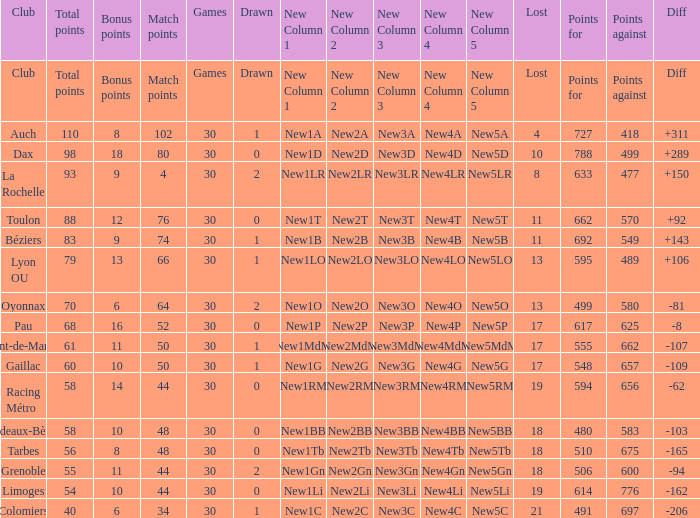What is the number of games for a club that has 34 match points? 30.0. 